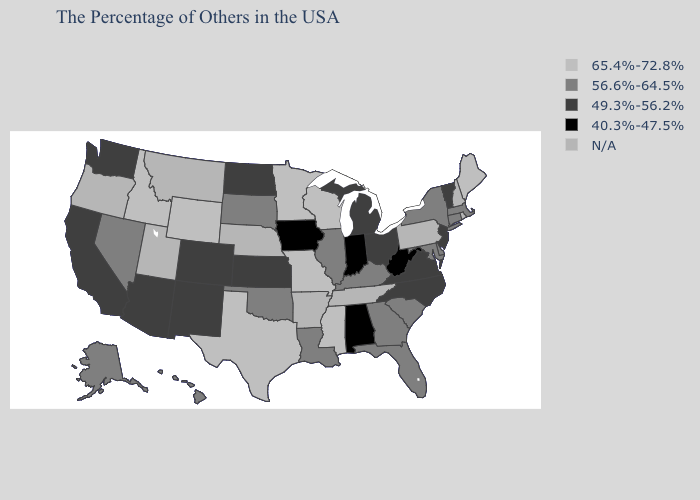Which states hav the highest value in the West?
Concise answer only. Wyoming, Idaho. Name the states that have a value in the range 40.3%-47.5%?
Answer briefly. West Virginia, Indiana, Alabama, Iowa. Which states have the lowest value in the South?
Short answer required. West Virginia, Alabama. Among the states that border California , which have the highest value?
Quick response, please. Nevada. What is the value of New Mexico?
Answer briefly. 49.3%-56.2%. What is the value of Minnesota?
Concise answer only. 65.4%-72.8%. What is the value of Washington?
Quick response, please. 49.3%-56.2%. Does the first symbol in the legend represent the smallest category?
Concise answer only. No. Name the states that have a value in the range N/A?
Write a very short answer. Rhode Island, New Hampshire, Pennsylvania, Tennessee, Arkansas, Nebraska, Utah, Montana, Oregon. Among the states that border Maryland , does West Virginia have the lowest value?
Answer briefly. Yes. How many symbols are there in the legend?
Concise answer only. 5. Does Hawaii have the highest value in the West?
Keep it brief. No. Does New Jersey have the lowest value in the Northeast?
Keep it brief. Yes. Does Iowa have the highest value in the USA?
Answer briefly. No. 